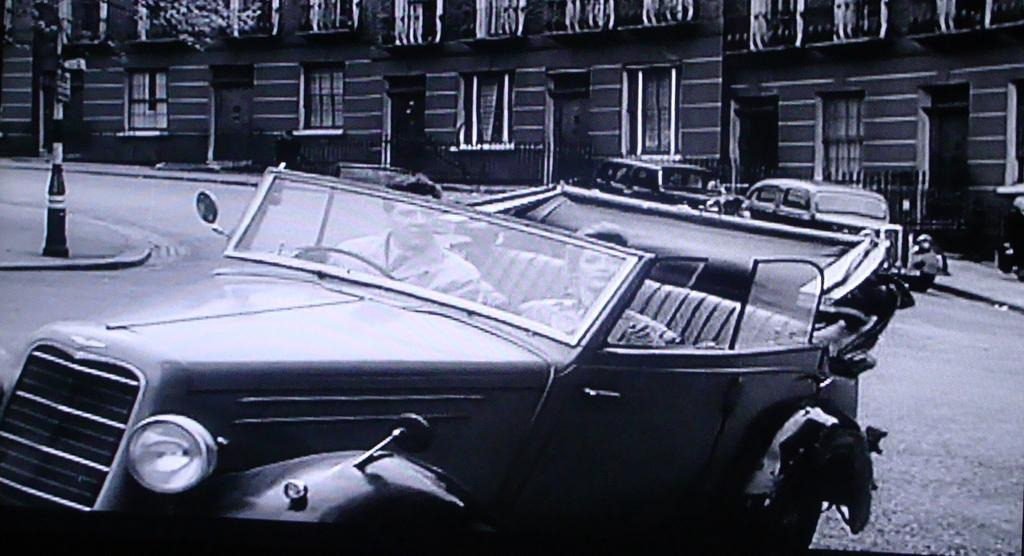What type of image is present in the picture? There is a black and white photograph in the image. Who is in the photograph? The photograph contains men and women. What are the men and women doing in the photograph? The men and women are sitting in a classic car. What are the people in the photograph doing with their gaze? The people in the photograph are looking into the camera. What can be seen in the background of the image? There is a building with glass windows in the background of the image. What type of chalk is being used by the people in the image? There is no chalk present in the image; it is a photograph of people sitting in a classic car. Can you describe the road on which the classic car is driving in the image? There is no road visible in the image; it is a photograph of people sitting in a classic car with a building in the background. 